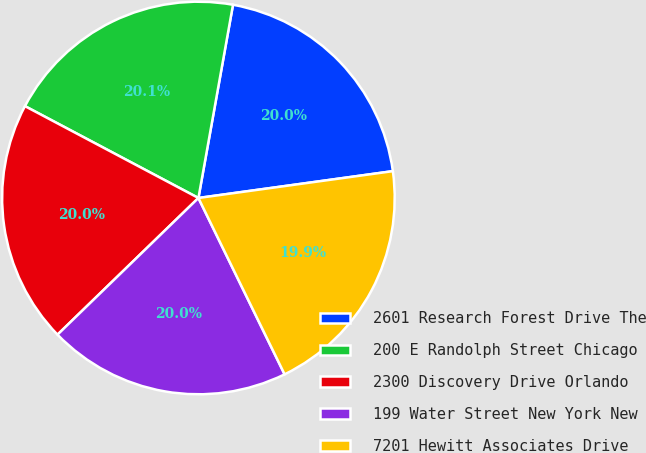<chart> <loc_0><loc_0><loc_500><loc_500><pie_chart><fcel>2601 Research Forest Drive The<fcel>200 E Randolph Street Chicago<fcel>2300 Discovery Drive Orlando<fcel>199 Water Street New York New<fcel>7201 Hewitt Associates Drive<nl><fcel>20.0%<fcel>20.07%<fcel>20.01%<fcel>19.98%<fcel>19.95%<nl></chart> 